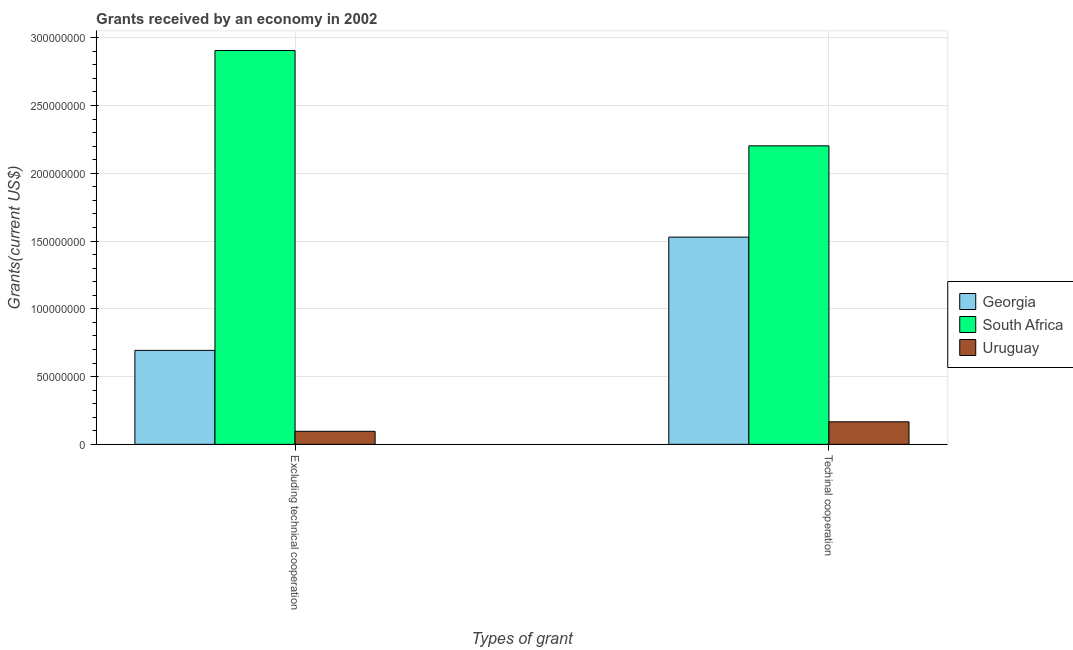Are the number of bars per tick equal to the number of legend labels?
Your answer should be very brief. Yes. How many bars are there on the 1st tick from the left?
Your answer should be very brief. 3. What is the label of the 1st group of bars from the left?
Offer a very short reply. Excluding technical cooperation. What is the amount of grants received(including technical cooperation) in Georgia?
Your response must be concise. 1.53e+08. Across all countries, what is the maximum amount of grants received(excluding technical cooperation)?
Provide a succinct answer. 2.91e+08. Across all countries, what is the minimum amount of grants received(excluding technical cooperation)?
Give a very brief answer. 9.63e+06. In which country was the amount of grants received(including technical cooperation) maximum?
Ensure brevity in your answer.  South Africa. In which country was the amount of grants received(including technical cooperation) minimum?
Provide a succinct answer. Uruguay. What is the total amount of grants received(including technical cooperation) in the graph?
Your response must be concise. 3.90e+08. What is the difference between the amount of grants received(including technical cooperation) in South Africa and that in Georgia?
Provide a succinct answer. 6.73e+07. What is the difference between the amount of grants received(including technical cooperation) in South Africa and the amount of grants received(excluding technical cooperation) in Georgia?
Provide a succinct answer. 1.51e+08. What is the average amount of grants received(excluding technical cooperation) per country?
Make the answer very short. 1.23e+08. What is the difference between the amount of grants received(excluding technical cooperation) and amount of grants received(including technical cooperation) in Georgia?
Provide a succinct answer. -8.35e+07. What is the ratio of the amount of grants received(excluding technical cooperation) in Uruguay to that in Georgia?
Keep it short and to the point. 0.14. In how many countries, is the amount of grants received(including technical cooperation) greater than the average amount of grants received(including technical cooperation) taken over all countries?
Your answer should be compact. 2. What does the 1st bar from the left in Excluding technical cooperation represents?
Your answer should be compact. Georgia. What does the 1st bar from the right in Excluding technical cooperation represents?
Give a very brief answer. Uruguay. How many bars are there?
Your response must be concise. 6. Are all the bars in the graph horizontal?
Ensure brevity in your answer.  No. How many countries are there in the graph?
Make the answer very short. 3. What is the difference between two consecutive major ticks on the Y-axis?
Your response must be concise. 5.00e+07. Where does the legend appear in the graph?
Your answer should be compact. Center right. How many legend labels are there?
Keep it short and to the point. 3. What is the title of the graph?
Your answer should be very brief. Grants received by an economy in 2002. What is the label or title of the X-axis?
Offer a very short reply. Types of grant. What is the label or title of the Y-axis?
Provide a short and direct response. Grants(current US$). What is the Grants(current US$) of Georgia in Excluding technical cooperation?
Make the answer very short. 6.93e+07. What is the Grants(current US$) in South Africa in Excluding technical cooperation?
Offer a terse response. 2.91e+08. What is the Grants(current US$) in Uruguay in Excluding technical cooperation?
Ensure brevity in your answer.  9.63e+06. What is the Grants(current US$) of Georgia in Techinal cooperation?
Provide a succinct answer. 1.53e+08. What is the Grants(current US$) of South Africa in Techinal cooperation?
Your response must be concise. 2.20e+08. What is the Grants(current US$) in Uruguay in Techinal cooperation?
Ensure brevity in your answer.  1.66e+07. Across all Types of grant, what is the maximum Grants(current US$) in Georgia?
Offer a terse response. 1.53e+08. Across all Types of grant, what is the maximum Grants(current US$) in South Africa?
Make the answer very short. 2.91e+08. Across all Types of grant, what is the maximum Grants(current US$) of Uruguay?
Offer a terse response. 1.66e+07. Across all Types of grant, what is the minimum Grants(current US$) in Georgia?
Ensure brevity in your answer.  6.93e+07. Across all Types of grant, what is the minimum Grants(current US$) of South Africa?
Keep it short and to the point. 2.20e+08. Across all Types of grant, what is the minimum Grants(current US$) of Uruguay?
Make the answer very short. 9.63e+06. What is the total Grants(current US$) of Georgia in the graph?
Provide a short and direct response. 2.22e+08. What is the total Grants(current US$) in South Africa in the graph?
Give a very brief answer. 5.11e+08. What is the total Grants(current US$) in Uruguay in the graph?
Offer a terse response. 2.62e+07. What is the difference between the Grants(current US$) in Georgia in Excluding technical cooperation and that in Techinal cooperation?
Your answer should be very brief. -8.35e+07. What is the difference between the Grants(current US$) in South Africa in Excluding technical cooperation and that in Techinal cooperation?
Your answer should be very brief. 7.03e+07. What is the difference between the Grants(current US$) in Uruguay in Excluding technical cooperation and that in Techinal cooperation?
Your answer should be compact. -6.99e+06. What is the difference between the Grants(current US$) of Georgia in Excluding technical cooperation and the Grants(current US$) of South Africa in Techinal cooperation?
Your response must be concise. -1.51e+08. What is the difference between the Grants(current US$) in Georgia in Excluding technical cooperation and the Grants(current US$) in Uruguay in Techinal cooperation?
Provide a short and direct response. 5.27e+07. What is the difference between the Grants(current US$) of South Africa in Excluding technical cooperation and the Grants(current US$) of Uruguay in Techinal cooperation?
Your answer should be compact. 2.74e+08. What is the average Grants(current US$) of Georgia per Types of grant?
Ensure brevity in your answer.  1.11e+08. What is the average Grants(current US$) of South Africa per Types of grant?
Your answer should be compact. 2.55e+08. What is the average Grants(current US$) of Uruguay per Types of grant?
Offer a very short reply. 1.31e+07. What is the difference between the Grants(current US$) of Georgia and Grants(current US$) of South Africa in Excluding technical cooperation?
Ensure brevity in your answer.  -2.21e+08. What is the difference between the Grants(current US$) of Georgia and Grants(current US$) of Uruguay in Excluding technical cooperation?
Offer a terse response. 5.97e+07. What is the difference between the Grants(current US$) in South Africa and Grants(current US$) in Uruguay in Excluding technical cooperation?
Provide a succinct answer. 2.81e+08. What is the difference between the Grants(current US$) in Georgia and Grants(current US$) in South Africa in Techinal cooperation?
Provide a succinct answer. -6.73e+07. What is the difference between the Grants(current US$) in Georgia and Grants(current US$) in Uruguay in Techinal cooperation?
Make the answer very short. 1.36e+08. What is the difference between the Grants(current US$) of South Africa and Grants(current US$) of Uruguay in Techinal cooperation?
Keep it short and to the point. 2.04e+08. What is the ratio of the Grants(current US$) of Georgia in Excluding technical cooperation to that in Techinal cooperation?
Your answer should be very brief. 0.45. What is the ratio of the Grants(current US$) of South Africa in Excluding technical cooperation to that in Techinal cooperation?
Your answer should be compact. 1.32. What is the ratio of the Grants(current US$) in Uruguay in Excluding technical cooperation to that in Techinal cooperation?
Your answer should be very brief. 0.58. What is the difference between the highest and the second highest Grants(current US$) in Georgia?
Your answer should be very brief. 8.35e+07. What is the difference between the highest and the second highest Grants(current US$) of South Africa?
Your answer should be very brief. 7.03e+07. What is the difference between the highest and the second highest Grants(current US$) in Uruguay?
Keep it short and to the point. 6.99e+06. What is the difference between the highest and the lowest Grants(current US$) of Georgia?
Your answer should be very brief. 8.35e+07. What is the difference between the highest and the lowest Grants(current US$) in South Africa?
Provide a short and direct response. 7.03e+07. What is the difference between the highest and the lowest Grants(current US$) of Uruguay?
Keep it short and to the point. 6.99e+06. 